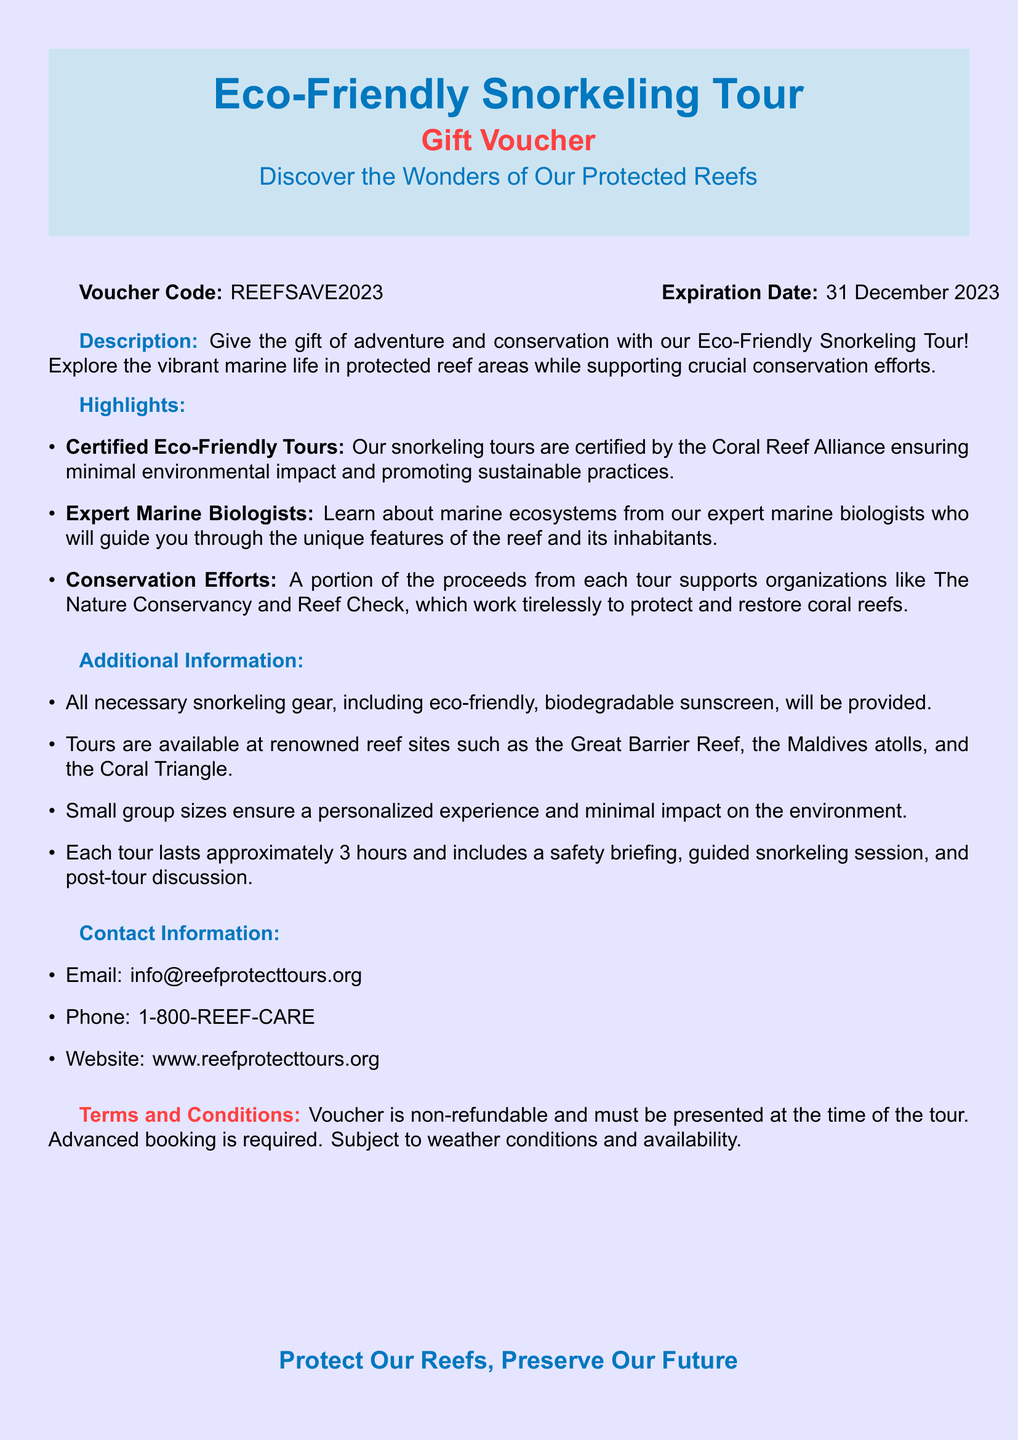What is the voucher code? The voucher code is clearly presented in the document under "Voucher Code."
Answer: REEFSAVE2023 What is the expiration date of the voucher? The expiration date is mentioned in the same section as the voucher code.
Answer: 31 December 2023 What type of sunscreen is provided? The document specifies the type of sunscreen included in the snorkeling gear.
Answer: Eco-friendly, biodegradable How long does each tour last? The duration of the tour is stated in the additional information section.
Answer: Approximately 3 hours Which organization supports conservation efforts from the tours? The document lists organizations that benefit from the tour proceeds.
Answer: The Nature Conservancy and Reef Check What are the renowned reef sites mentioned? The document lists renowned sites under the additional information.
Answer: Great Barrier Reef, the Maldives atolls, Coral Triangle What is the primary focus of the eco-friendly snorkeling tour? The primary focus is mentioned in the description of the tour.
Answer: Adventure and conservation What is required for booking the tour? The document mentions the requirement for booking in the terms and conditions.
Answer: Advanced booking How are the tour group sizes characterized? The size of the tour groups is described in the additional information section.
Answer: Small group sizes 